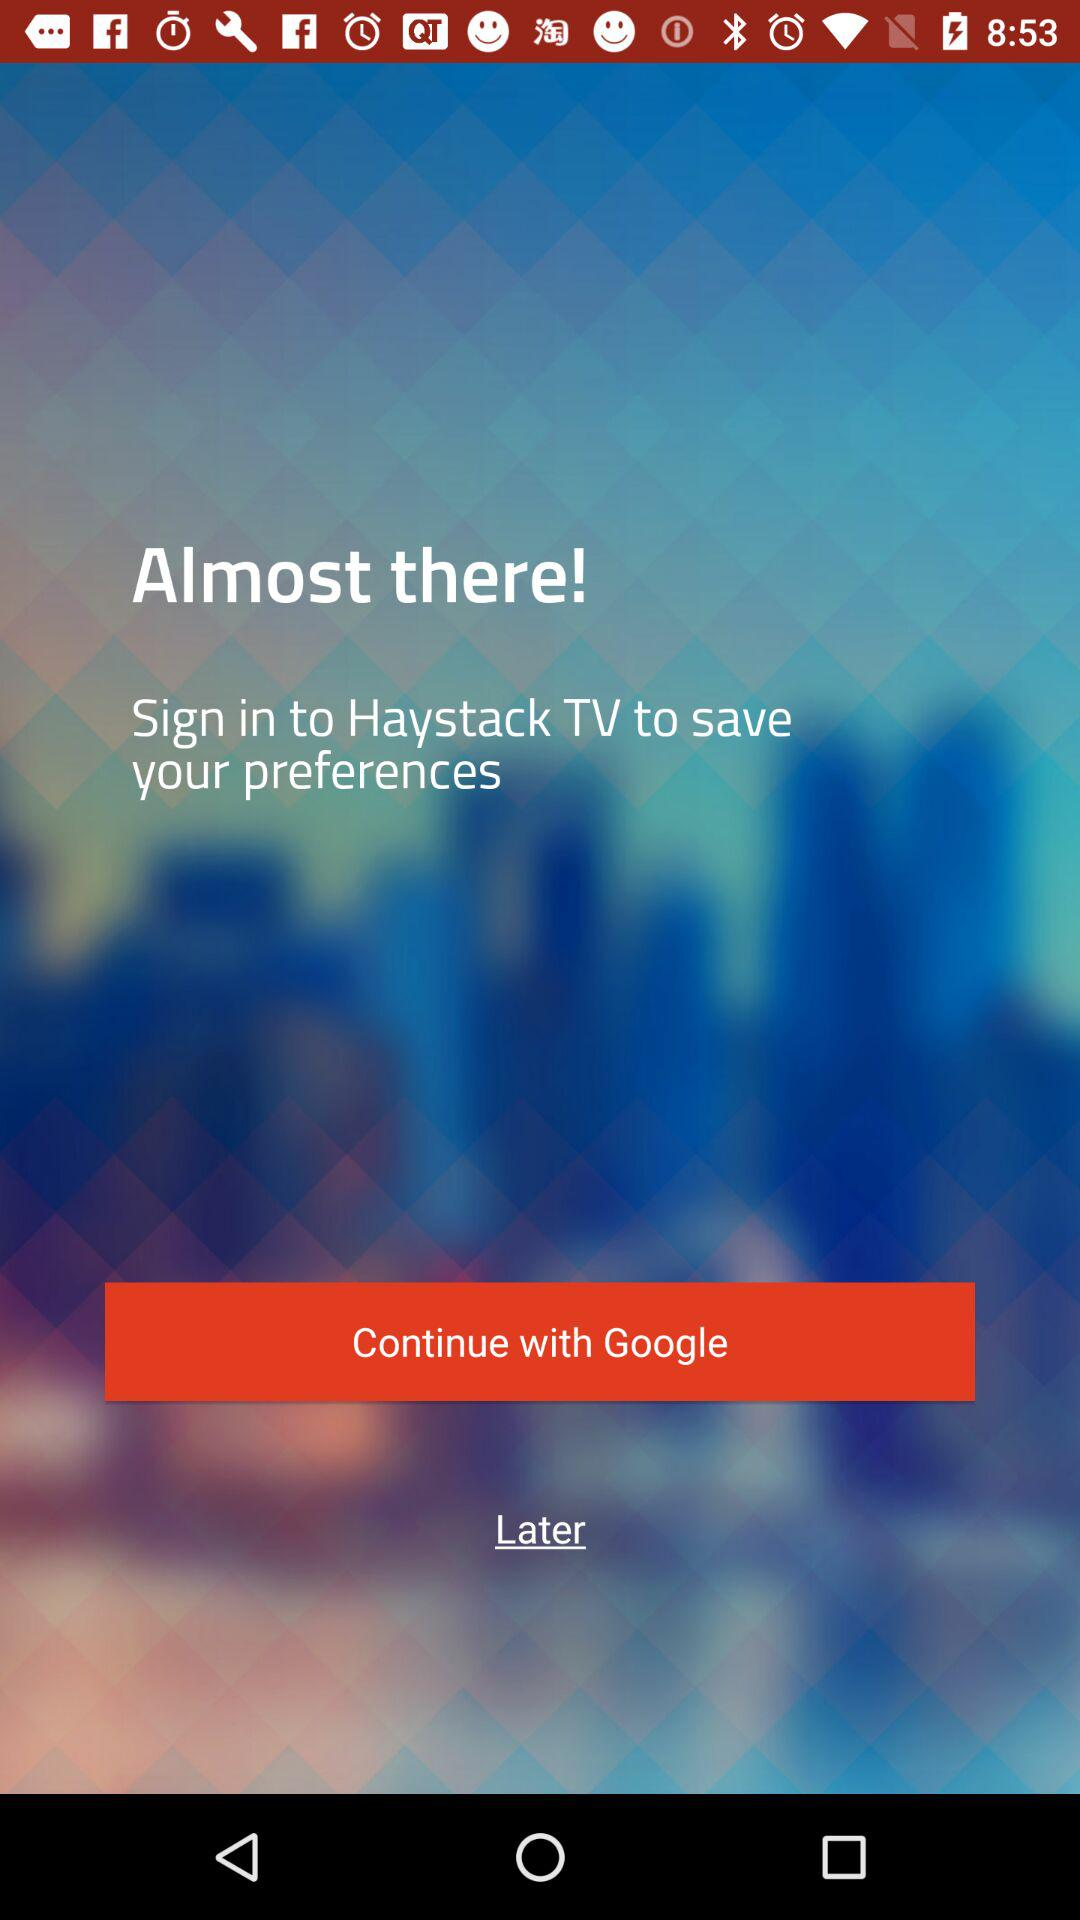What account can be used to sign up? The account that can be used to sign up is "Google". 